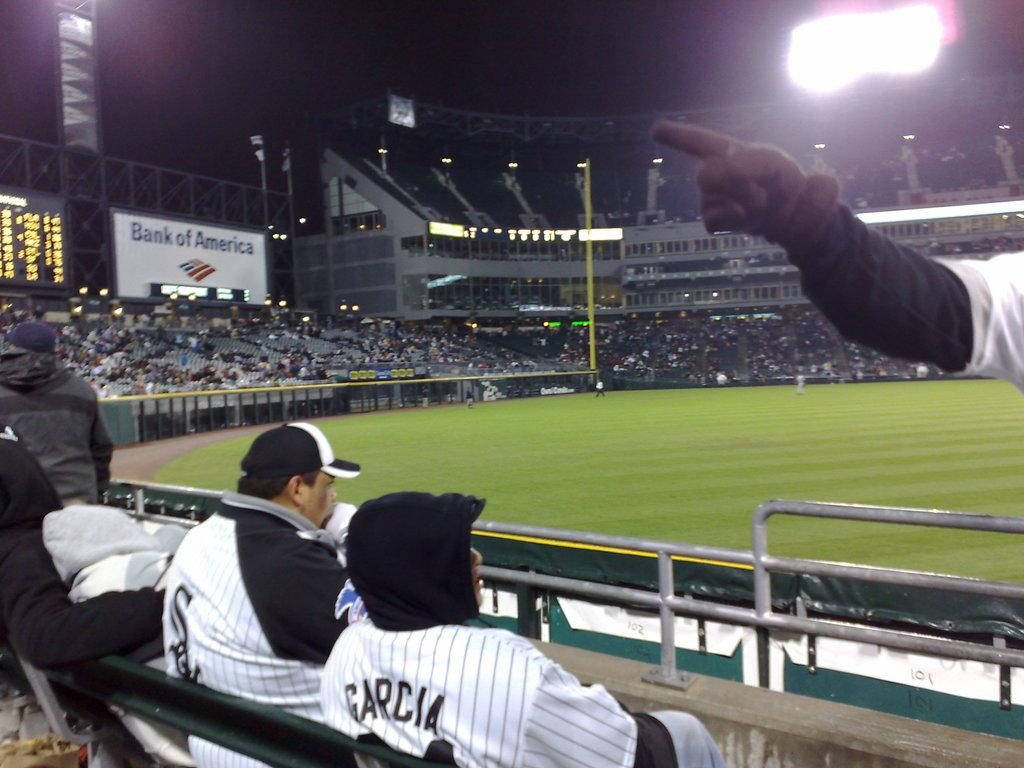<image>
Describe the image concisely. two fans sitting and watching a sports game wearing matching shirts one of them says garcia on the back. 